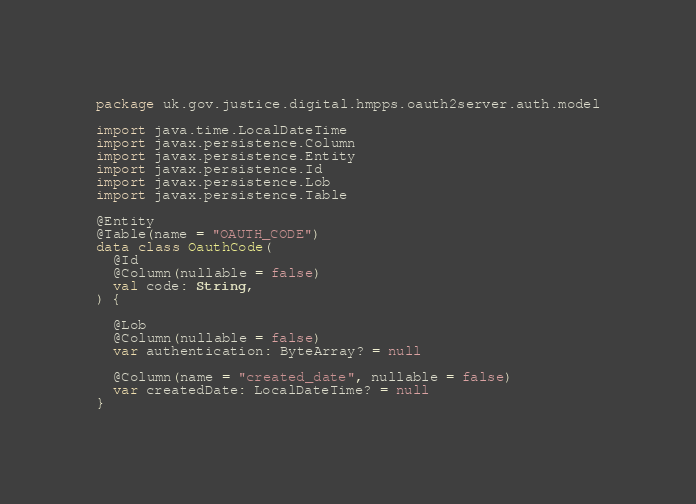Convert code to text. <code><loc_0><loc_0><loc_500><loc_500><_Kotlin_>package uk.gov.justice.digital.hmpps.oauth2server.auth.model

import java.time.LocalDateTime
import javax.persistence.Column
import javax.persistence.Entity
import javax.persistence.Id
import javax.persistence.Lob
import javax.persistence.Table

@Entity
@Table(name = "OAUTH_CODE")
data class OauthCode(
  @Id
  @Column(nullable = false)
  val code: String,
) {

  @Lob
  @Column(nullable = false)
  var authentication: ByteArray? = null

  @Column(name = "created_date", nullable = false)
  var createdDate: LocalDateTime? = null
}
</code> 